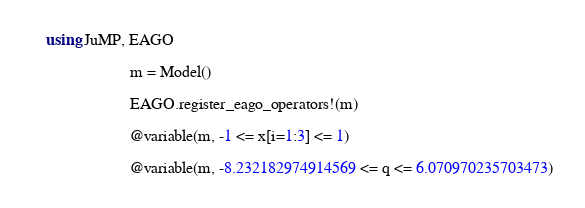<code> <loc_0><loc_0><loc_500><loc_500><_Julia_>using JuMP, EAGO

                     m = Model()

                     EAGO.register_eago_operators!(m)

                     @variable(m, -1 <= x[i=1:3] <= 1)

                     @variable(m, -8.232182974914569 <= q <= 6.070970235703473)
</code> 